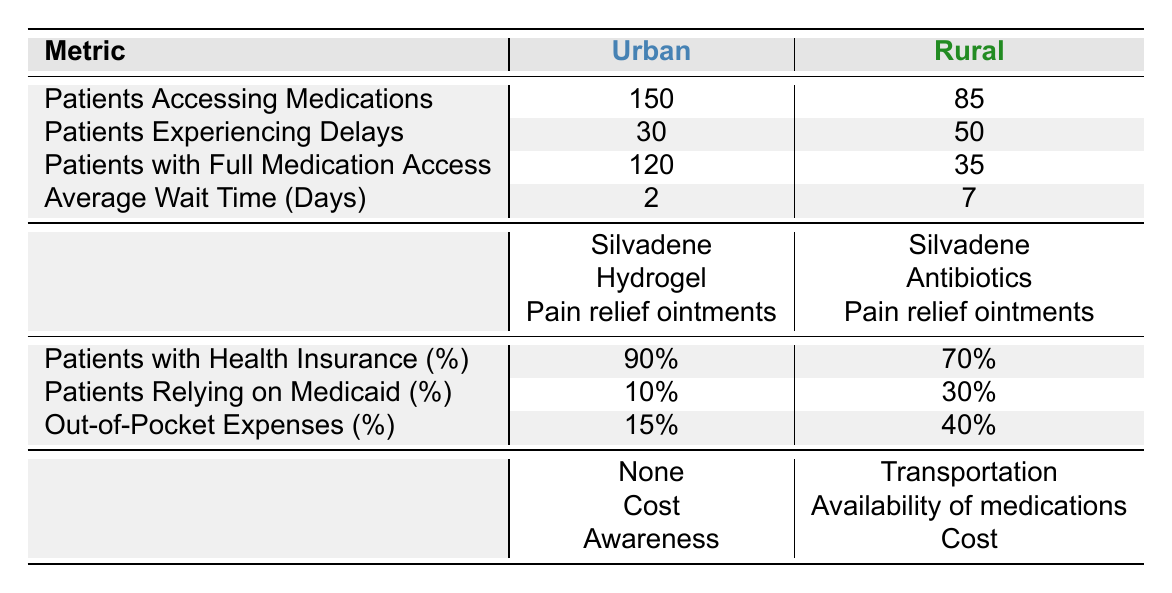What percentage of urban patients have health insurance? Referring to the row for health insurance percentage in the urban section, it states that 90% of urban patients have health insurance.
Answer: 90% What is the average wait time for medications in rural areas? In the table, under rural data, it specifies that the average wait time for medications is 7 days.
Answer: 7 days How many more patients access medications in urban areas compared to rural areas? From the table, 150 urban patients access medications while 85 rural patients do. The difference is calculated as 150 - 85 = 65.
Answer: 65 Do more patients in urban areas experience delays accessing medications than in rural areas? The table shows that 30 patients in urban areas experience delays, while 50 in rural areas do. Therefore, more patients in rural areas experience delays.
Answer: No What are the common medications needed by rural patients that are not needed by urban patients? The table lists common medications needed: for urban patients, 'Silvadene', 'Hydrogel', and 'Pain relief ointments' are required, while rural patients need 'Silvadene', 'Antibiotics', and 'Pain relief ointments'. The unique medication needed by rural patients is 'Antibiotics'.
Answer: Antibiotics What is the percentage of rural patients relying on Medicaid? The rural section indicates that 30% of patients rely on Medicaid.
Answer: 30% If a patient incurs an out-of-pocket expense of 40% in rural areas, how does this compare to urban areas? According to the table, urban areas have out-of-pocket expenses of 15%. The difference in expenses between rural and urban areas is calculated as 40% - 15% = 25%. Rural patients incur 25% more out-of-pocket expenses compared to urban patients.
Answer: 25% more What is the main barrier for urban patients listed in the table? Under the main barriers for urban patients, it states that the listed barriers include 'None', 'Cost', and 'Awareness'. Hence, at least one main barrier is indicated.
Answer: Cost (among others) 